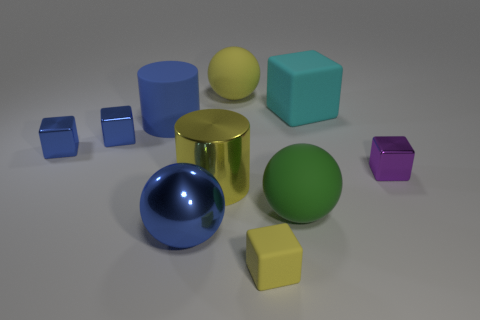Subtract all yellow cubes. How many cubes are left? 4 Subtract all yellow cubes. How many cubes are left? 4 Subtract all red cubes. Subtract all purple balls. How many cubes are left? 5 Subtract all cylinders. How many objects are left? 8 Subtract 0 green cubes. How many objects are left? 10 Subtract all purple shiny cubes. Subtract all tiny rubber things. How many objects are left? 8 Add 7 purple metallic things. How many purple metallic things are left? 8 Add 7 large blue objects. How many large blue objects exist? 9 